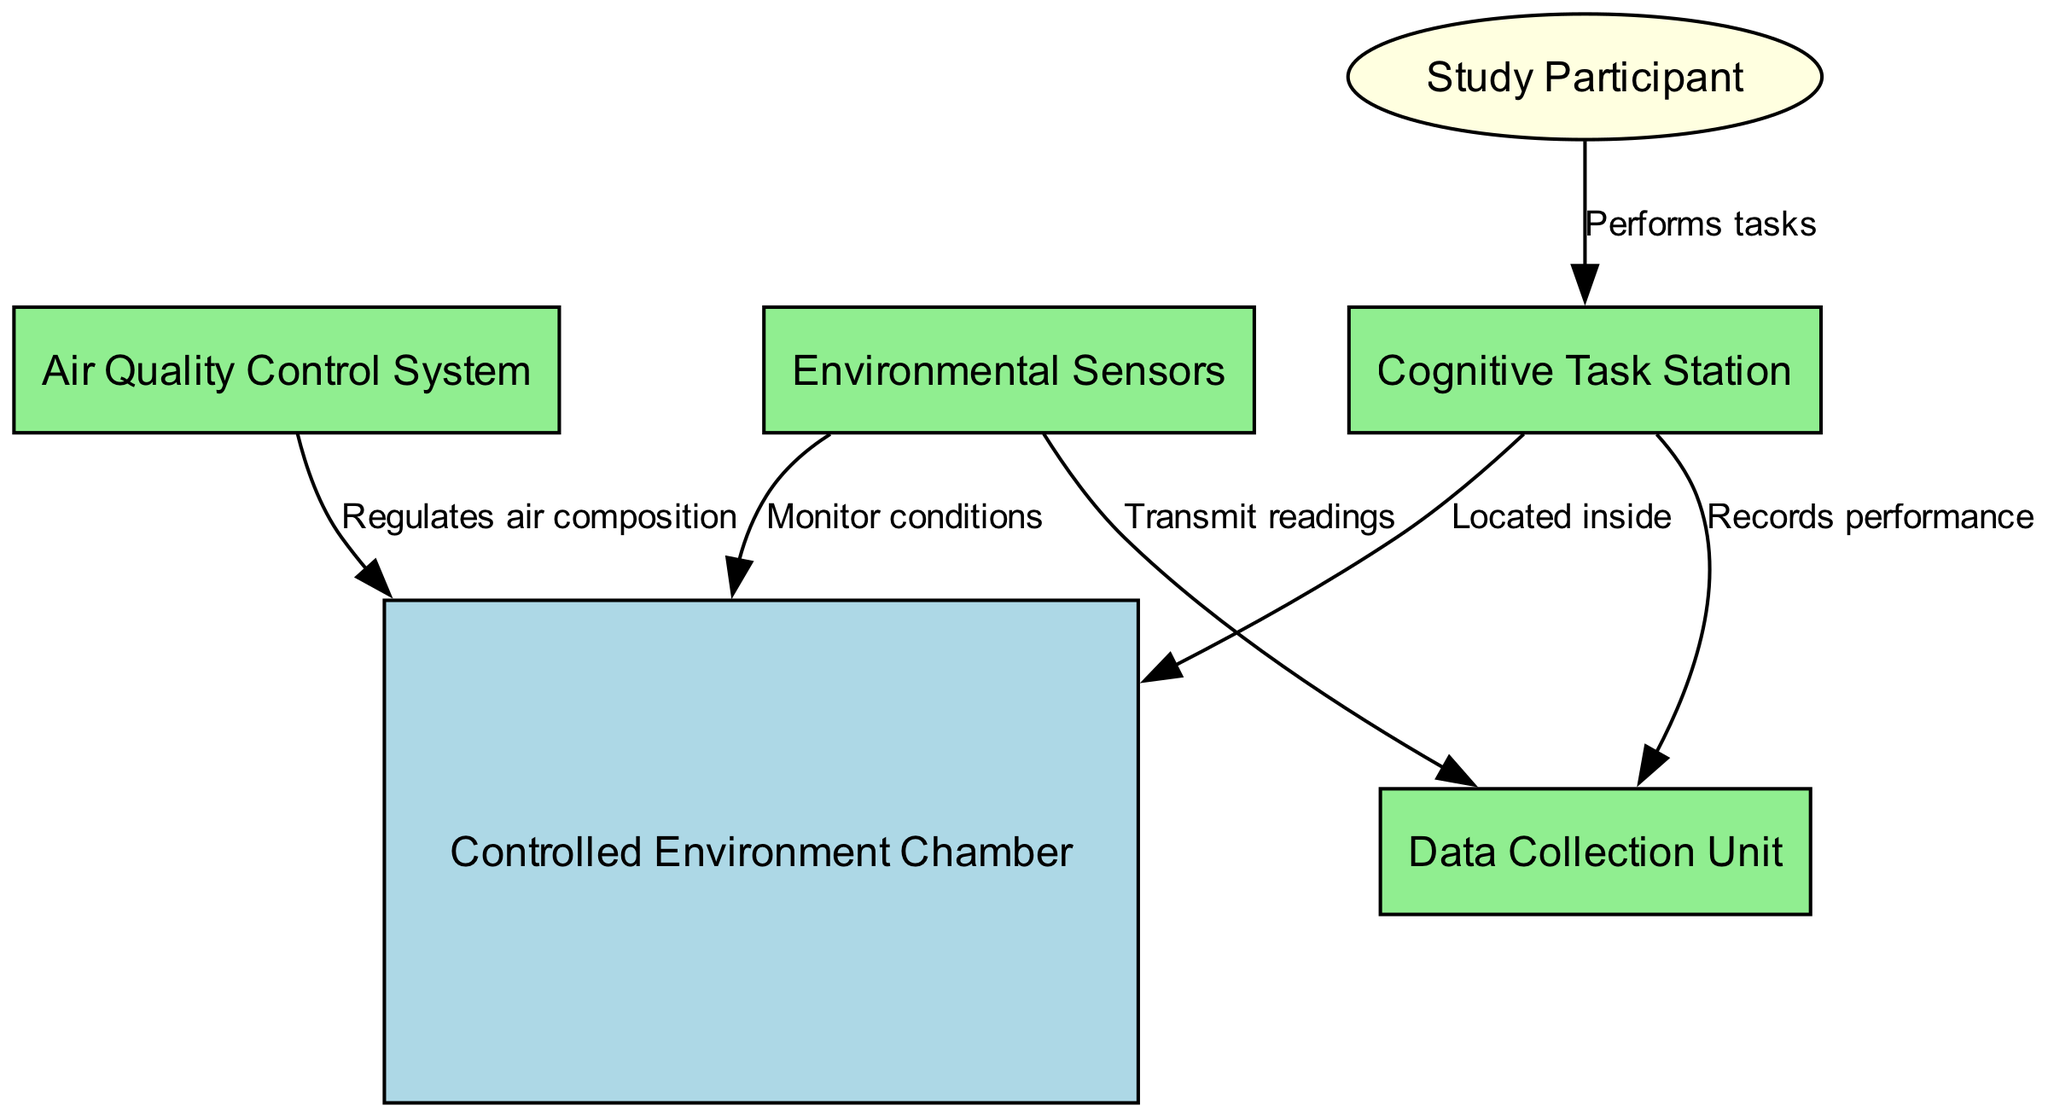What is the central component of the chamber? The central component is the "Controlled Environment Chamber" as depicted in the diagram. It serves as the primary environment where all interactions occur.
Answer: Controlled Environment Chamber How many environmental sensors are represented in the diagram? The diagram shows one "Environmental Sensors" node. This indicates that there is a single unit responsible for monitoring various environmental conditions.
Answer: One Which element regulates the air composition within the chamber? The "Air Quality Control System" is the element responsible for regulating air composition, as indicated by the directed edge pointing towards the chamber.
Answer: Air Quality Control System What does the "Data Collection Unit" do in relation to the cognitive task? The "Data Collection Unit" records performance, which indicates it gathers data on how well the tasks are being performed by participants.
Answer: Records performance How many distinct interactions (edges) are represented in the diagram? The diagram shows six distinct interactions (edges) that connect the nodes, reflecting various relationships and flows of function within the chamber setup.
Answer: Six What is the role of participants in the study? Participants perform tasks at the "Cognitive Task Station," indicating their active involvement in the study and interaction with the cognitive tasks presented.
Answer: Performs tasks Which component transmits readings to the data collection unit? The "Environmental Sensors" are responsible for transmitting readings directly to the "Data Collection Unit," facilitating data acquisition for analysis.
Answer: Environmental Sensors What is located inside the controlled environment chamber? The "Cognitive Task Station" is located inside the "Controlled Environment Chamber," meaning this area is set up for participants to engage with cognitive tasks.
Answer: Cognitive Task Station Which node is represented as an ellipse in the diagram? The "Study Participant" is represented as an ellipse, distinguishing it from the other components in the chamber setup that utilize box shapes.
Answer: Study Participant 